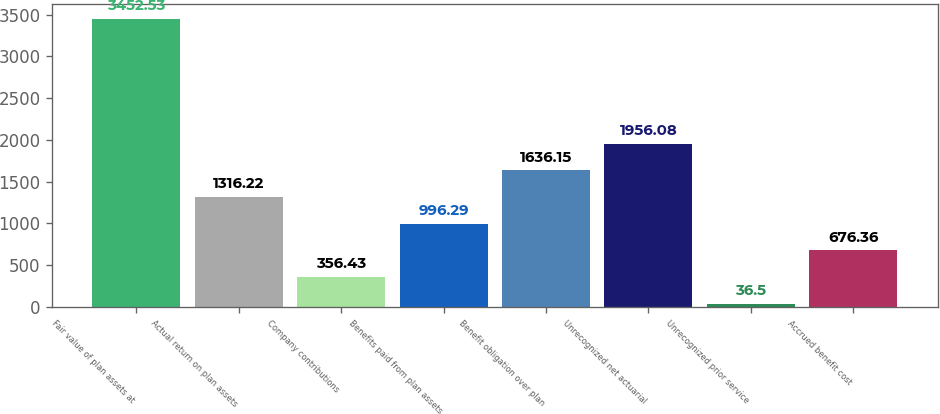Convert chart to OTSL. <chart><loc_0><loc_0><loc_500><loc_500><bar_chart><fcel>Fair value of plan assets at<fcel>Actual return on plan assets<fcel>Company contributions<fcel>Benefits paid from plan assets<fcel>Benefit obligation over plan<fcel>Unrecognized net actuarial<fcel>Unrecognized prior service<fcel>Accrued benefit cost<nl><fcel>3452.53<fcel>1316.22<fcel>356.43<fcel>996.29<fcel>1636.15<fcel>1956.08<fcel>36.5<fcel>676.36<nl></chart> 